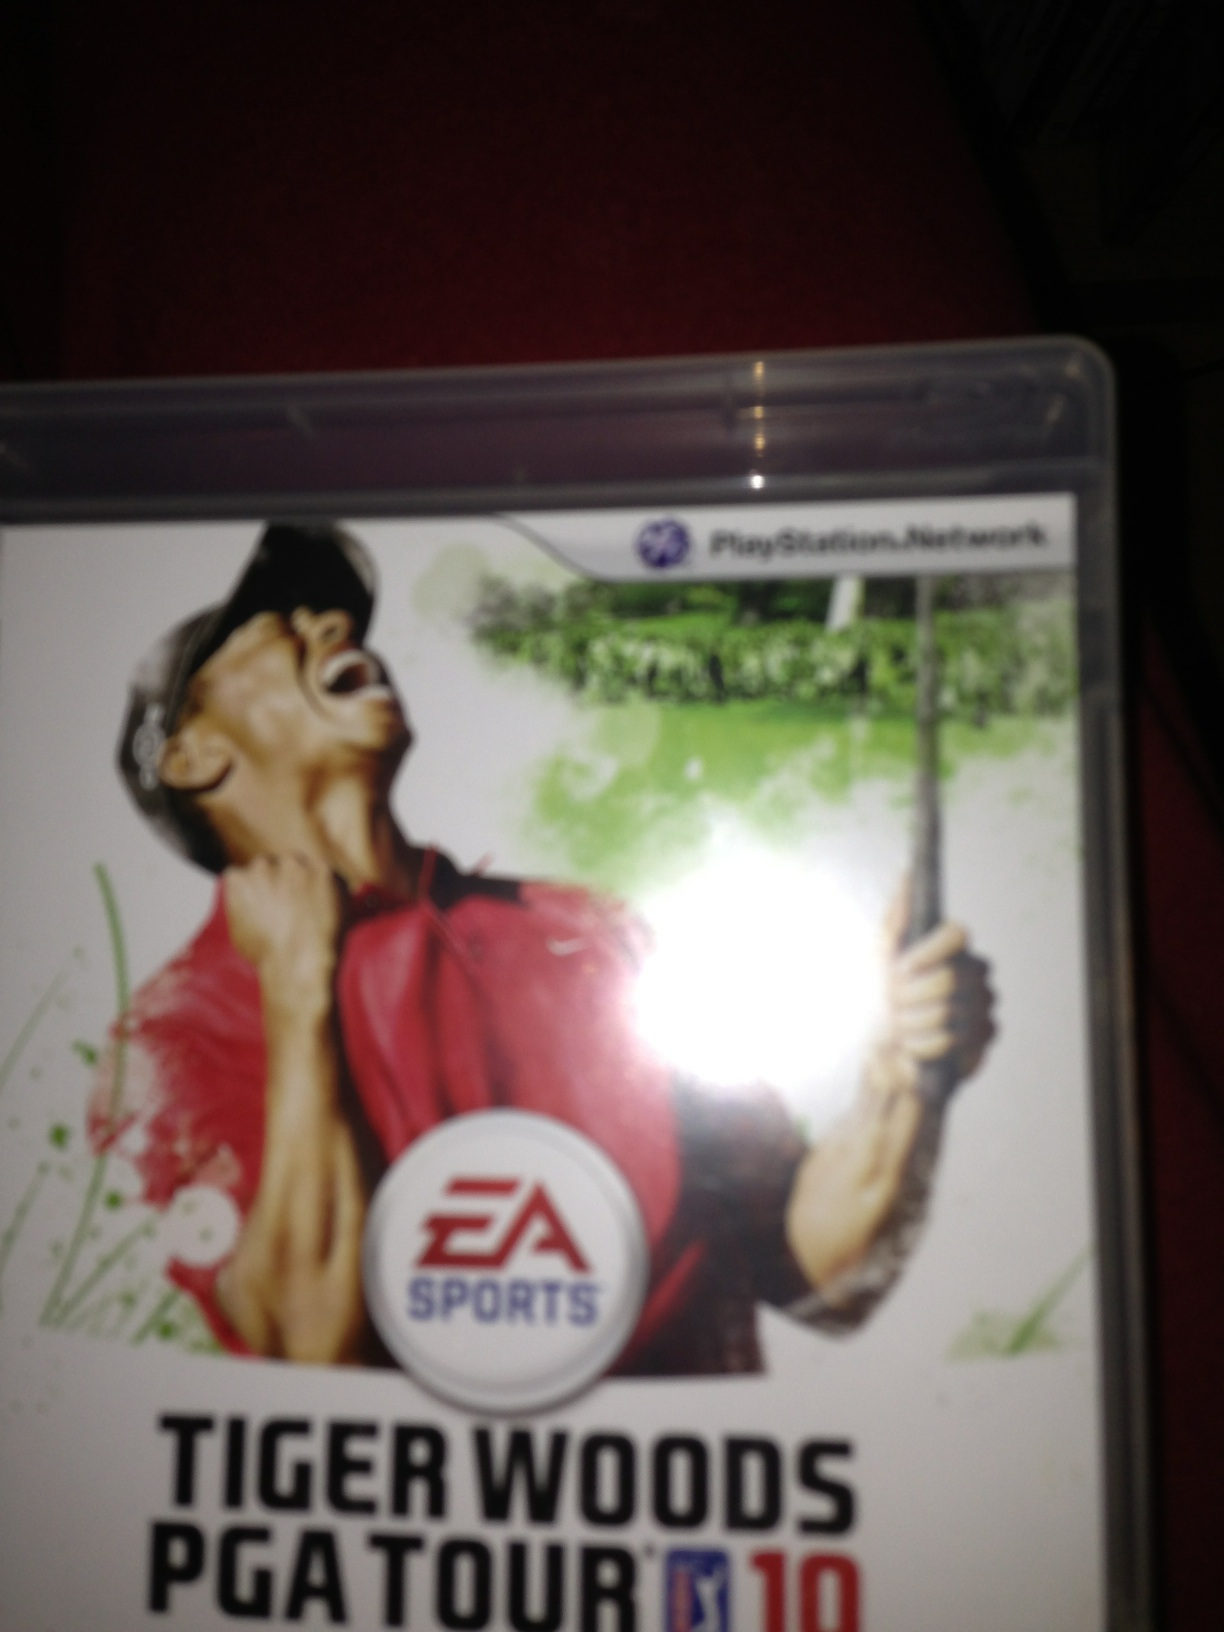How would you explain the significance of the U.S. Open inclusion in this game to a non-gamer? The inclusion of the U.S. Open in 'Tiger Woods PGA Tour 10' is quite significant as it represents one of the four major championships in professional golf, akin to the importance of the Super Bowl in American football or the World Cup in soccer. Having the U.S. Open in the game elevates its authenticity, offering players a chance to experience the prestige and rigorous competition associated with this historic event. It signifies the game's dedication to providing a realistic and comprehensive golfing experience. 